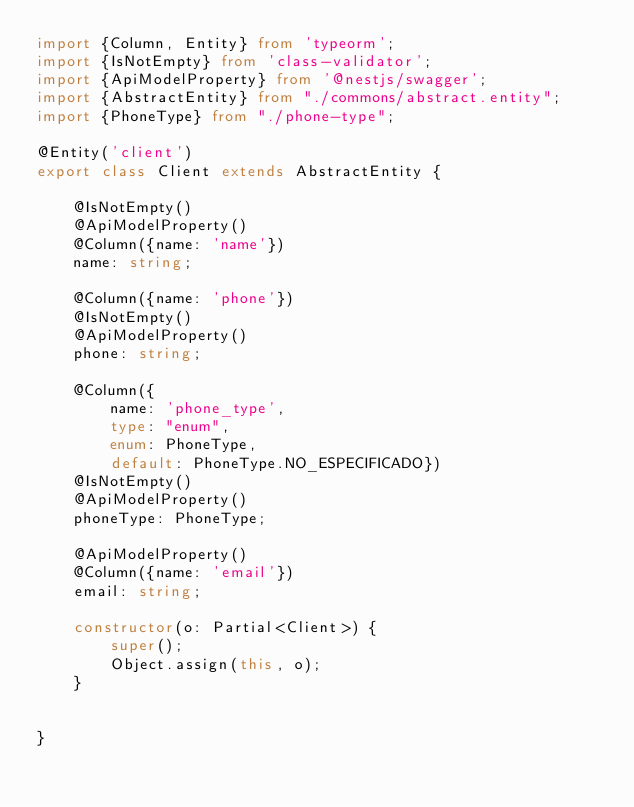<code> <loc_0><loc_0><loc_500><loc_500><_TypeScript_>import {Column, Entity} from 'typeorm';
import {IsNotEmpty} from 'class-validator';
import {ApiModelProperty} from '@nestjs/swagger';
import {AbstractEntity} from "./commons/abstract.entity";
import {PhoneType} from "./phone-type";

@Entity('client')
export class Client extends AbstractEntity {

    @IsNotEmpty()
    @ApiModelProperty()
    @Column({name: 'name'})
    name: string;

    @Column({name: 'phone'})
    @IsNotEmpty()
    @ApiModelProperty()
    phone: string;

    @Column({
        name: 'phone_type',
        type: "enum",
        enum: PhoneType,
        default: PhoneType.NO_ESPECIFICADO})
    @IsNotEmpty()
    @ApiModelProperty()
    phoneType: PhoneType;

    @ApiModelProperty()
    @Column({name: 'email'})
    email: string;

    constructor(o: Partial<Client>) {
        super();
        Object.assign(this, o);
    }


}
</code> 